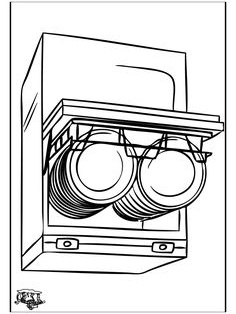You are given a sketch of an object. Tell me the name of the object in the image. The image depicts a built-in dishwasher, recognizable by features such as the racks for holding kitchenware and controls typically seen on such appliances. These dishwashers are commonly installed under kitchen countertops. The image shows the door ajar, exposing the vertical arrangement of racks designed to accommodate various sizes of dishes and utensils. Dishwashers like this help streamline kitchen chores by automatically cleaning dishes using water and detergent. 